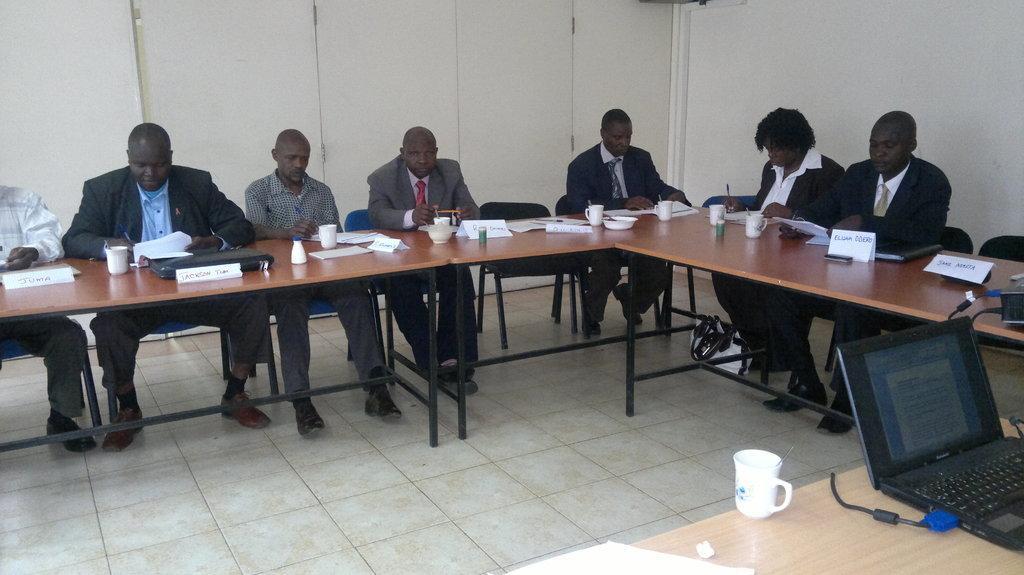In one or two sentences, can you explain what this image depicts? As we can see in the image there is a white color wall and chairs. On chairs there are few people sitting. In front of them there is a table. On table there is a laptop, poster, glasses and walls. 